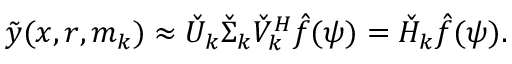<formula> <loc_0><loc_0><loc_500><loc_500>\tilde { y } ( x , r , m _ { k } ) \approx \check { U } _ { k } \check { \Sigma } _ { k } \check { V } _ { k } ^ { H } \hat { f } ( \psi ) = \check { H } _ { k } \hat { f } ( \psi ) .</formula> 